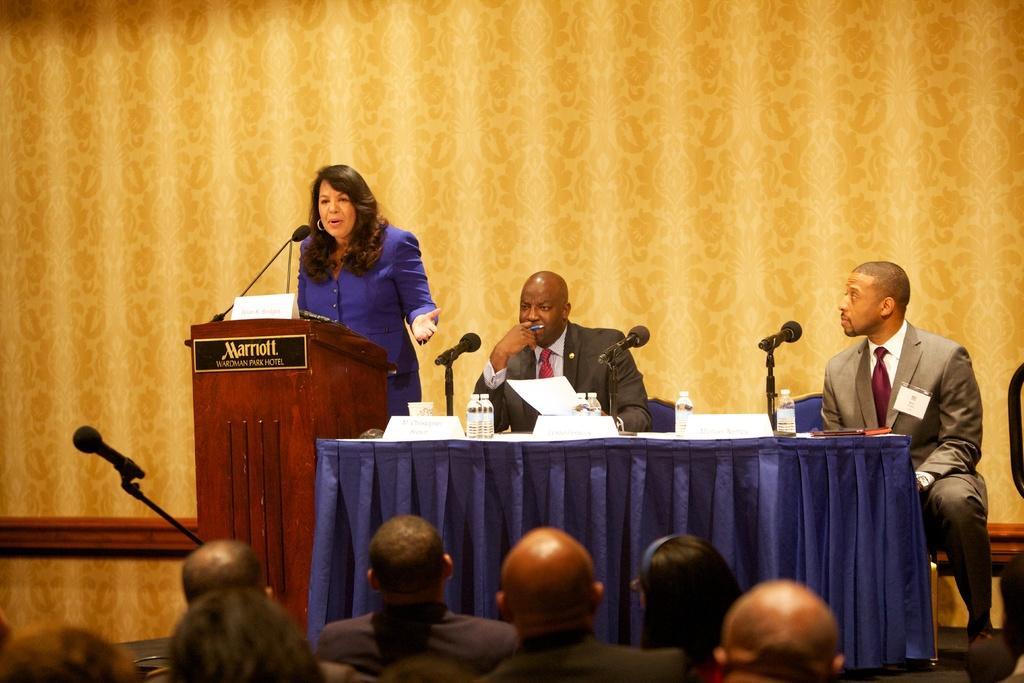How would you summarize this image in a sentence or two? In this image there is a woman standing near the podium and speaking through the mic which is in front of her. Beside her there are two other person siting in the chairs. In front of them there is a table. On the table there are mice,bottle,papers and boards. At the bottom there are few people who are watching them. In the background there is a curtain. 